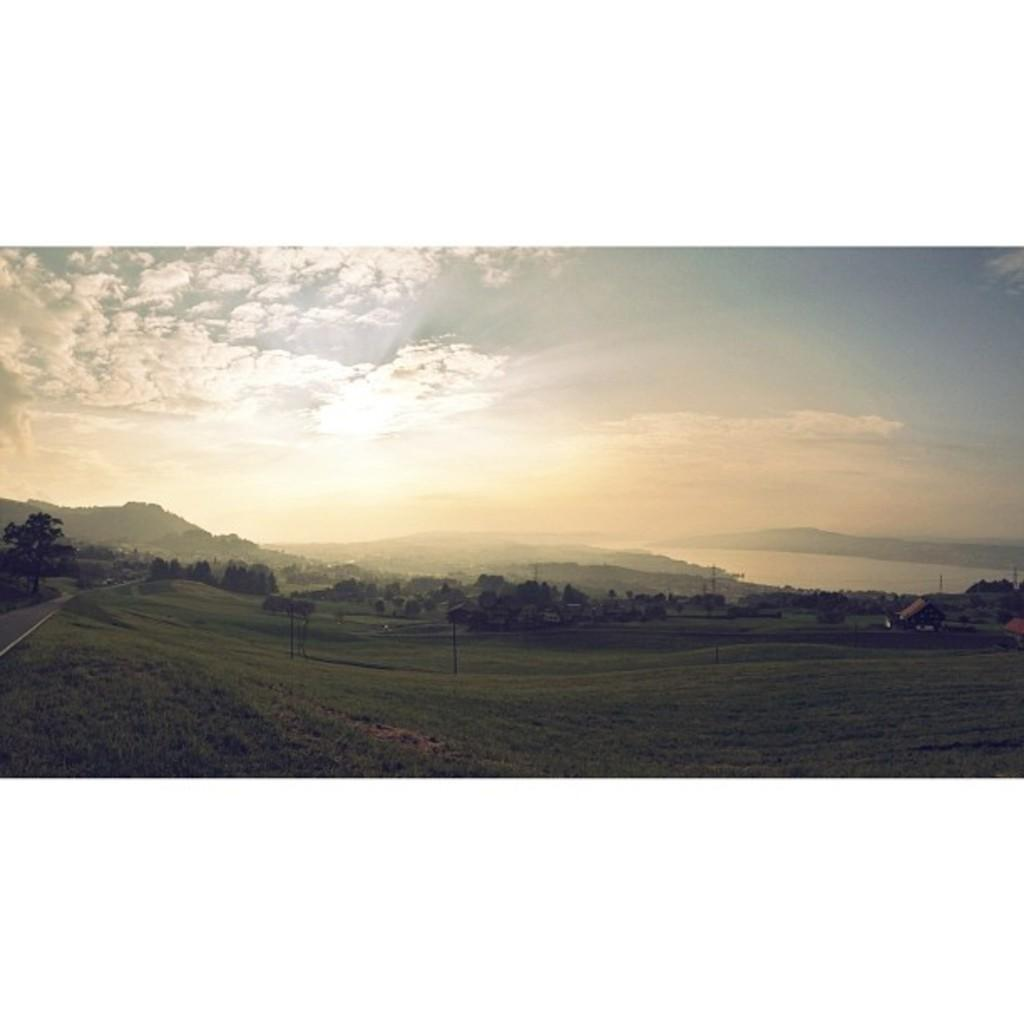What type of vegetation is present in the image? There is a large group of trees in the image. What type of structures can be seen in the image? There are houses with roofs in the image. What type of ground cover is visible in the image? There is grass in the image. What type of pathway is present in the image? There is a pathway in the image. What type of natural features can be seen in the background of the image? There are mountains and a large water body visible in the background. What is the condition of the sky in the image? The sky is visible and appears cloudy. Can you tell me where the parcel is located in the image? There is no parcel present in the image. What color is the balloon that the father is holding in the image? There is no balloon or father present in the image. 